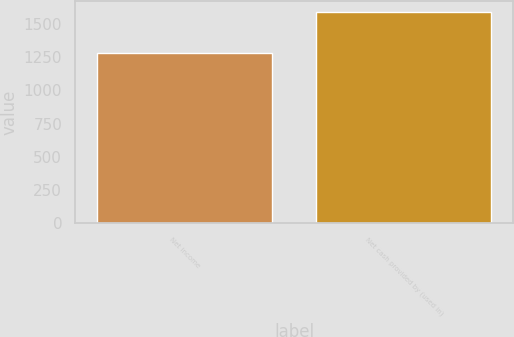Convert chart to OTSL. <chart><loc_0><loc_0><loc_500><loc_500><bar_chart><fcel>Net income<fcel>Net cash provided by (used in)<nl><fcel>1278<fcel>1589<nl></chart> 